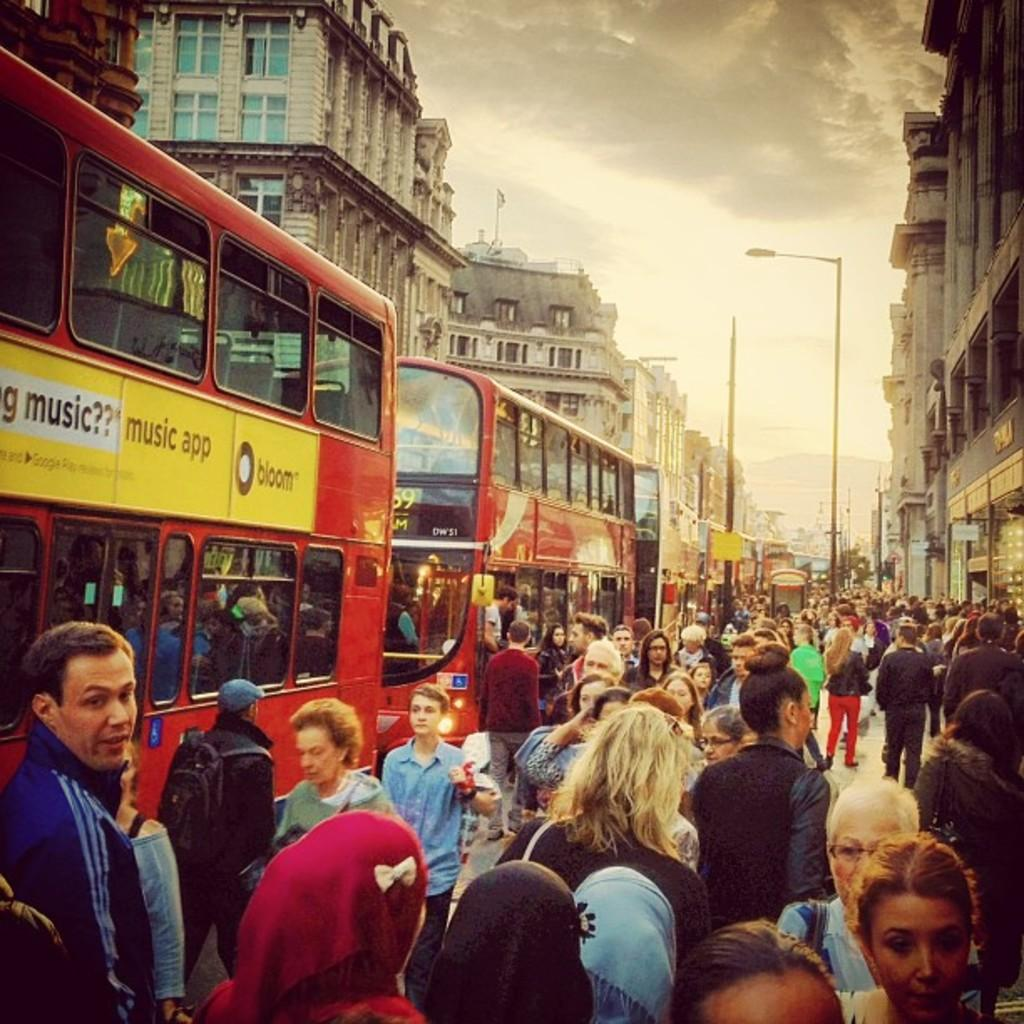<image>
Provide a brief description of the given image. A red bus with a yellow sign on the side that says bloom on the side. 